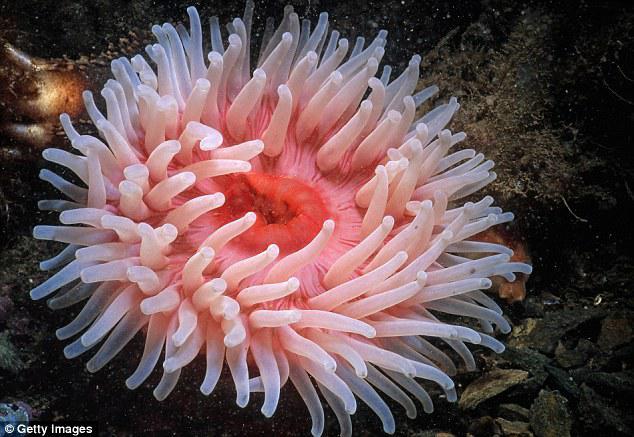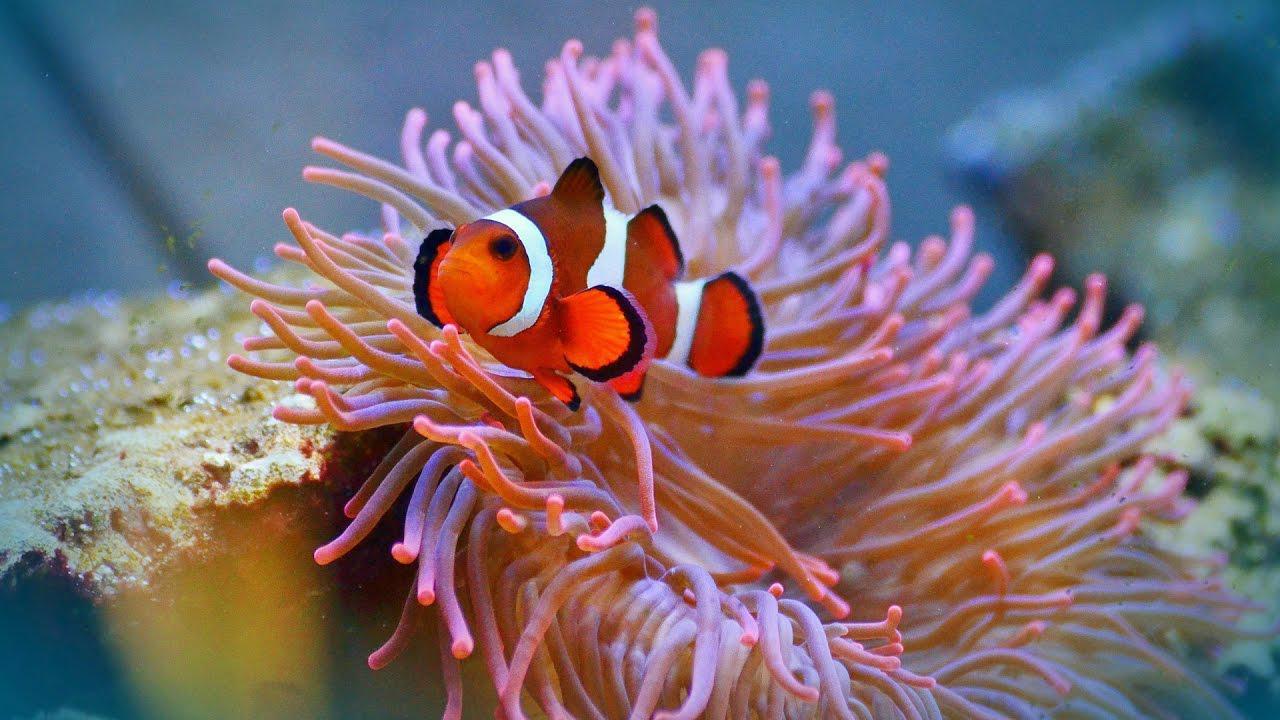The first image is the image on the left, the second image is the image on the right. For the images displayed, is the sentence "Exactly one clownfish swims near the center of an image, amid anemone tendrils." factually correct? Answer yes or no. Yes. 